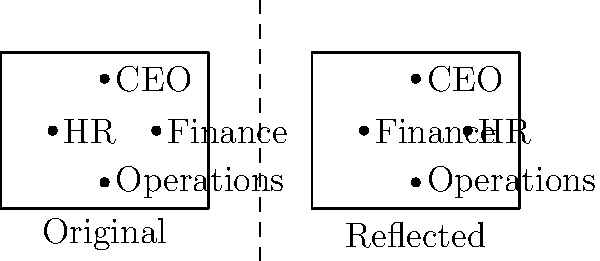An international nonprofit organization is considering restructuring its team across global offices. The current organizational chart is shown on the left side of the dashed line. If the organization wants to create a balanced team structure by reflecting this chart across the vertical axis, which department would be directly above the CEO in the reflected structure? To solve this problem, we need to understand the concept of reflection in transformational geometry:

1. Reflection across a vertical axis (in this case, the dashed line) flips the image horizontally.
2. Points closest to the reflection line will be closest on the other side after reflection.
3. The vertical distance from any point to the horizontal base remains the same after reflection.

Let's analyze the original structure:
1. The CEO is at the top center.
2. HR is on the left, below the CEO.
3. Finance is on the right, below the CEO.
4. Operations is at the bottom center.

Now, let's reflect this structure:
1. The CEO will remain at the top center in the reflected structure.
2. HR, being on the left, will move to the right side in the reflected structure.
3. Finance, being on the right, will move to the left side in the reflected structure.
4. Operations will remain at the bottom center in the reflected structure.

Therefore, after reflection, Finance will be directly above the CEO in the new structure.
Answer: Finance 